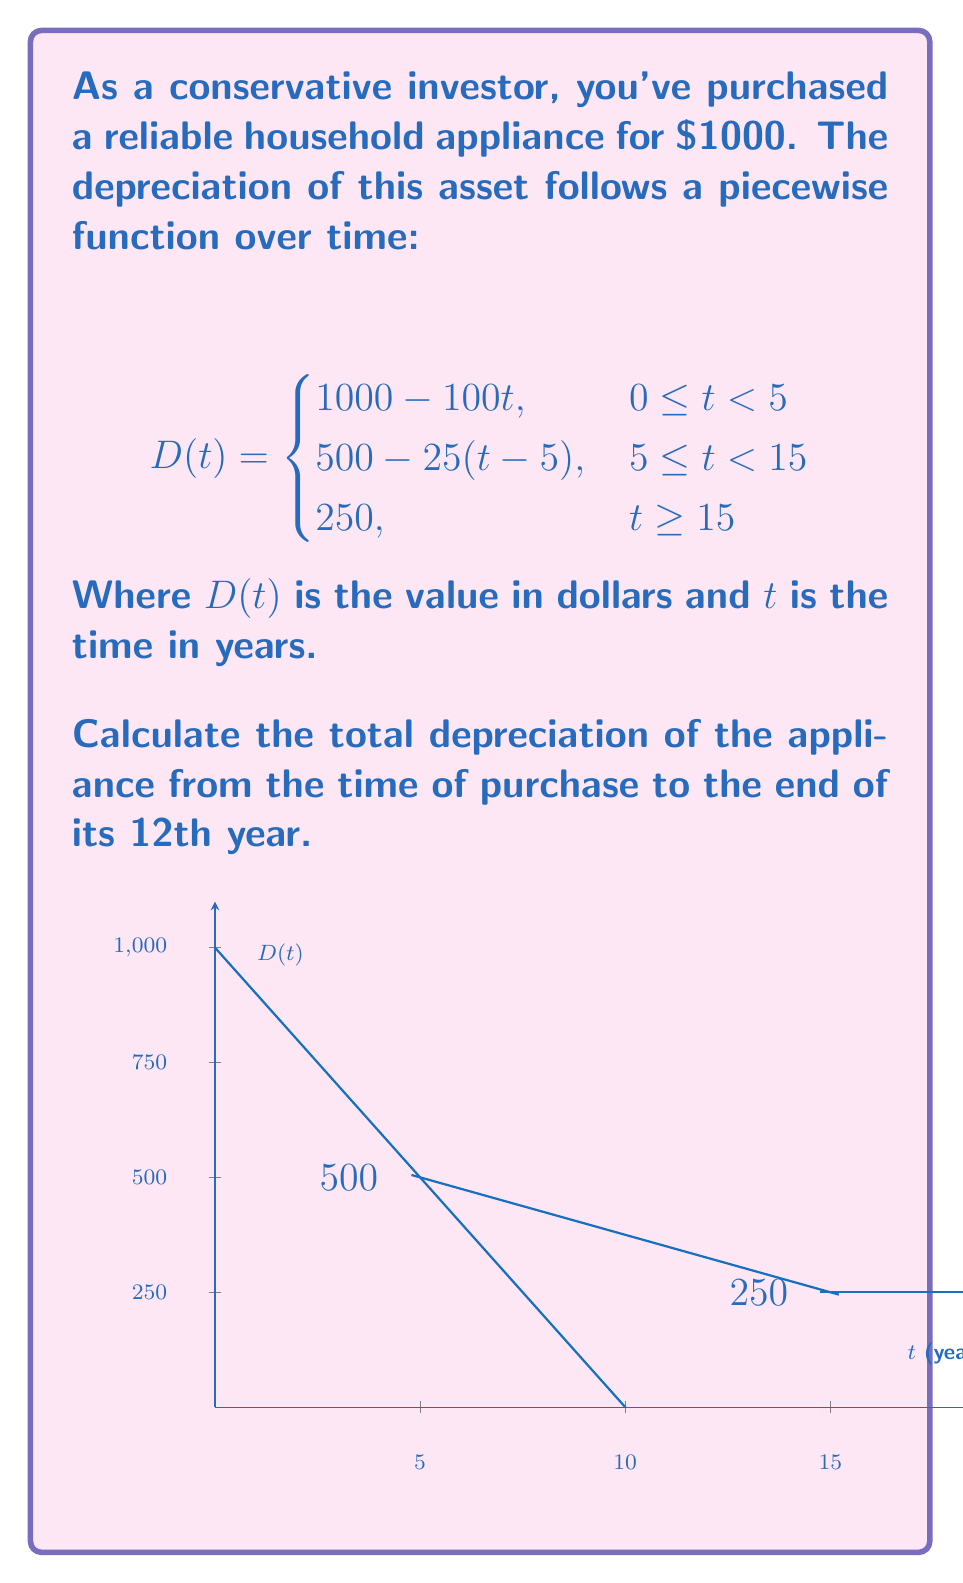Can you solve this math problem? Let's approach this step-by-step:

1) We need to find $D(0) - D(12)$, where $D(0)$ is the initial value and $D(12)$ is the value after 12 years.

2) Initial value, $D(0) = 1000$ (given in the question)

3) To find $D(12)$, we use the second piece of the function since $5 \leq 12 < 15$:

   $D(12) = 500 - 25(12-5)$
   
   $= 500 - 25(7)$
   
   $= 500 - 175$
   
   $= 325$

4) Now, we can calculate the total depreciation:

   Total Depreciation $= D(0) - D(12)$
   
   $= 1000 - 325$
   
   $= 675$

Therefore, the total depreciation over 12 years is $675.
Answer: $675 